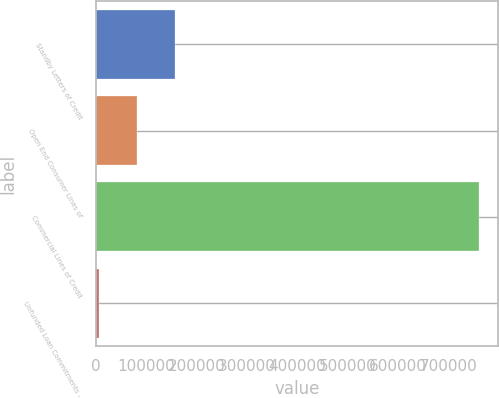Convert chart. <chart><loc_0><loc_0><loc_500><loc_500><bar_chart><fcel>Standby Letters of Credit<fcel>Open End Consumer Lines of<fcel>Commercial Lines of Credit<fcel>Unfunded Loan Commitments -<nl><fcel>157180<fcel>81796.1<fcel>760253<fcel>6412<nl></chart> 